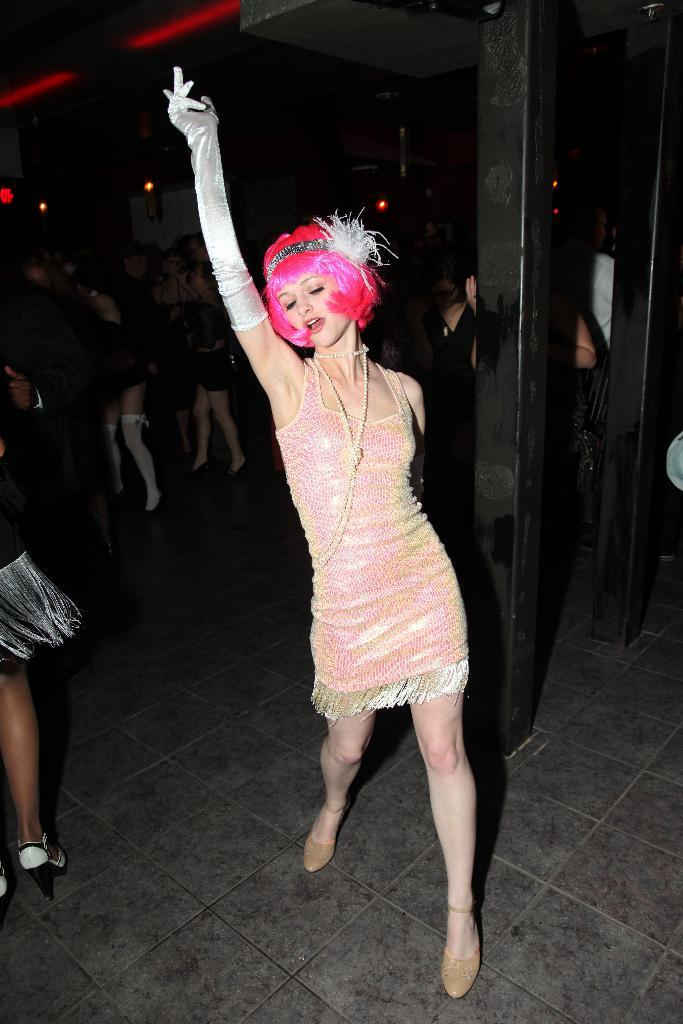What is happening with the groups of people in the image? The people are dancing on the floor. Can you describe the setting where the people are dancing? There is a pillar in the image, which suggests that the dancing is taking place in a room or hall with architectural features. What type of art can be seen on the legs of the people in the image? There is no art visible on the legs of the people in the image; they are dancing and not displaying any artwork. 